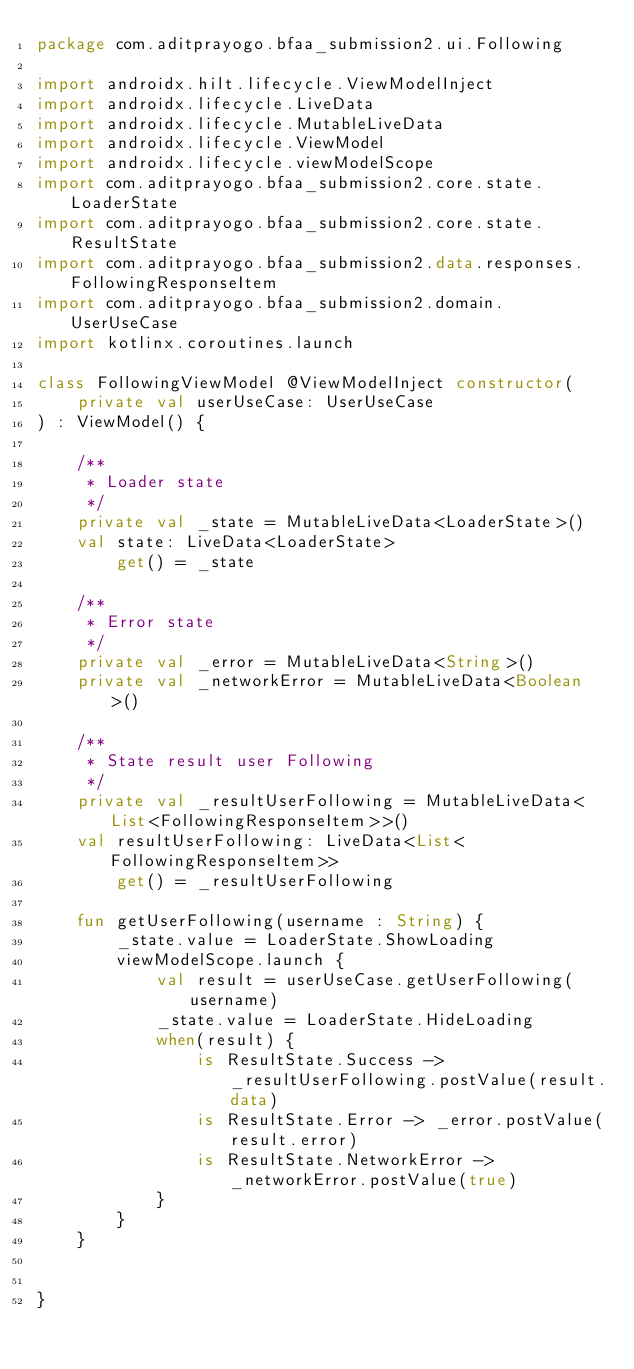Convert code to text. <code><loc_0><loc_0><loc_500><loc_500><_Kotlin_>package com.aditprayogo.bfaa_submission2.ui.Following

import androidx.hilt.lifecycle.ViewModelInject
import androidx.lifecycle.LiveData
import androidx.lifecycle.MutableLiveData
import androidx.lifecycle.ViewModel
import androidx.lifecycle.viewModelScope
import com.aditprayogo.bfaa_submission2.core.state.LoaderState
import com.aditprayogo.bfaa_submission2.core.state.ResultState
import com.aditprayogo.bfaa_submission2.data.responses.FollowingResponseItem
import com.aditprayogo.bfaa_submission2.domain.UserUseCase
import kotlinx.coroutines.launch

class FollowingViewModel @ViewModelInject constructor(
    private val userUseCase: UserUseCase
) : ViewModel() {

    /**
     * Loader state
     */
    private val _state = MutableLiveData<LoaderState>()
    val state: LiveData<LoaderState>
        get() = _state

    /**
     * Error state
     */
    private val _error = MutableLiveData<String>()
    private val _networkError = MutableLiveData<Boolean>()

    /**
     * State result user Following
     */
    private val _resultUserFollowing = MutableLiveData<List<FollowingResponseItem>>()
    val resultUserFollowing: LiveData<List<FollowingResponseItem>>
        get() = _resultUserFollowing

    fun getUserFollowing(username : String) {
        _state.value = LoaderState.ShowLoading
        viewModelScope.launch {
            val result = userUseCase.getUserFollowing(username)
            _state.value = LoaderState.HideLoading
            when(result) {
                is ResultState.Success -> _resultUserFollowing.postValue(result.data)
                is ResultState.Error -> _error.postValue(result.error)
                is ResultState.NetworkError -> _networkError.postValue(true)
            }
        }
    }


}</code> 